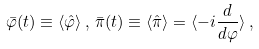<formula> <loc_0><loc_0><loc_500><loc_500>\bar { \varphi } ( t ) \equiv \langle \hat { \varphi } \rangle \, , \, \bar { \pi } ( t ) \equiv \langle \hat { \pi } \rangle = \langle - i \frac { d } { d \varphi } \rangle \, ,</formula> 